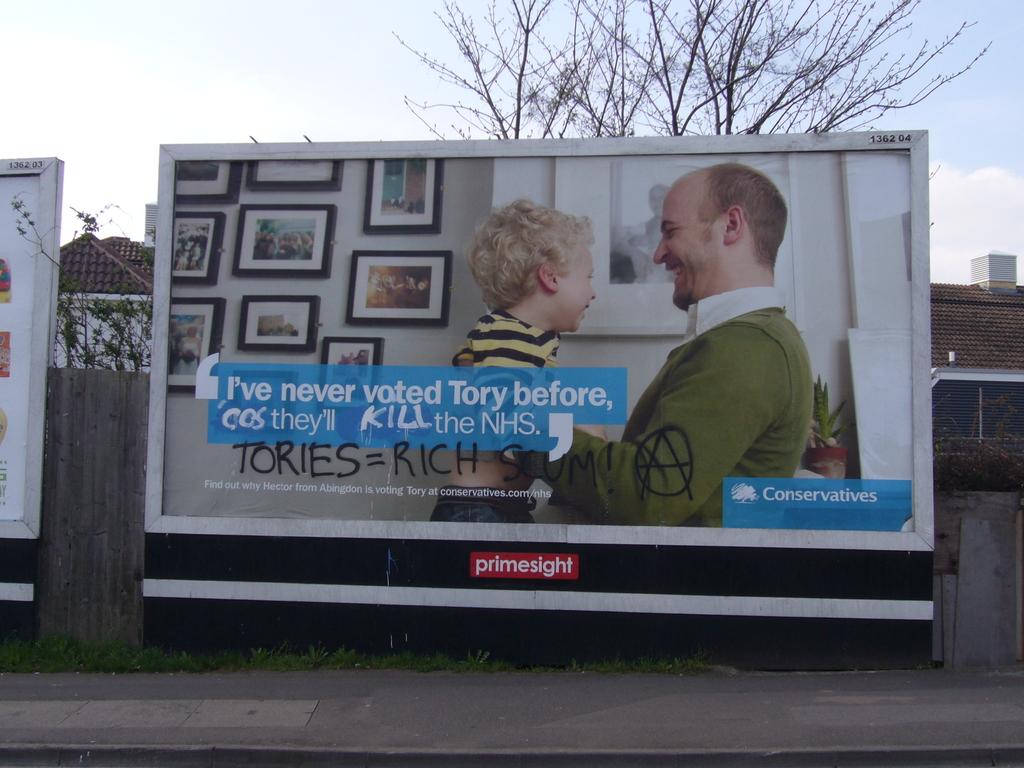What does the vandal say tories are?
Give a very brief answer. Rich. 